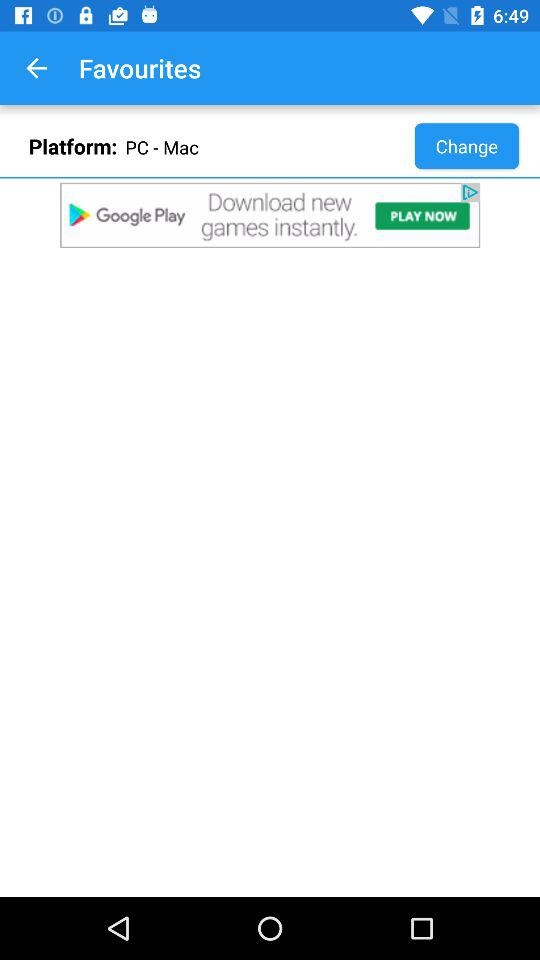What is the selected platform? The selected platform is "PC - Mac". 